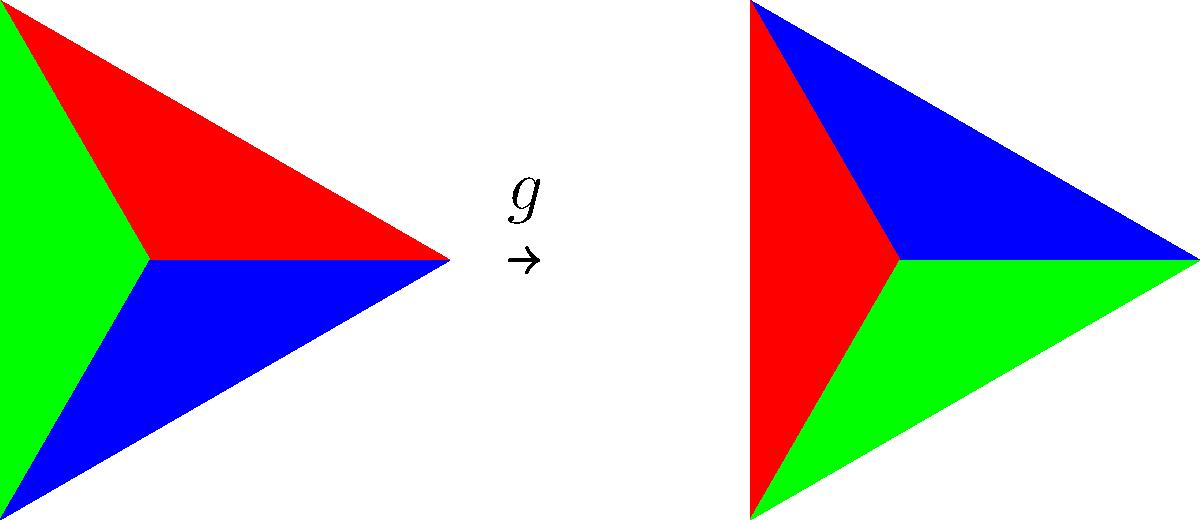In the context of color grading in film post-production, consider the group action of the cyclic group $C_3$ on the set of primary colors {Red, Green, Blue}. If $g$ represents a clockwise rotation by 120°, what is the orbit of the color Red under this group action? To find the orbit of Red under the group action of $C_3$, we need to follow these steps:

1. Understand the group action: The cyclic group $C_3$ acts on the set of primary colors {Red, Green, Blue} by rotation.

2. Identify the elements of $C_3$:
   - $e$: identity (no rotation)
   - $g$: clockwise rotation by 120°
   - $g^2$: clockwise rotation by 240° (equivalent to counterclockwise rotation by 120°)

3. Apply each group element to Red:
   - $e(Red) = Red$
   - $g(Red) = Blue$ (as shown in the diagram)
   - $g^2(Red) = Green$

4. The orbit of Red is the set of all colors that can be reached by applying the group elements to Red.

5. Therefore, the orbit of Red under this group action is {Red, Green, Blue}.

This result demonstrates how group theory can model color transformations in film post-production, allowing filmmakers to understand and manipulate color relationships systematically while maintaining artistic integrity.
Answer: {Red, Green, Blue} 